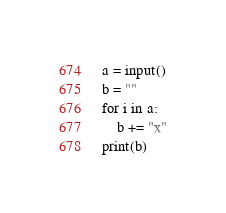<code> <loc_0><loc_0><loc_500><loc_500><_Python_>a = input()
b = ""
for i in a:
    b += "x"
print(b)</code> 